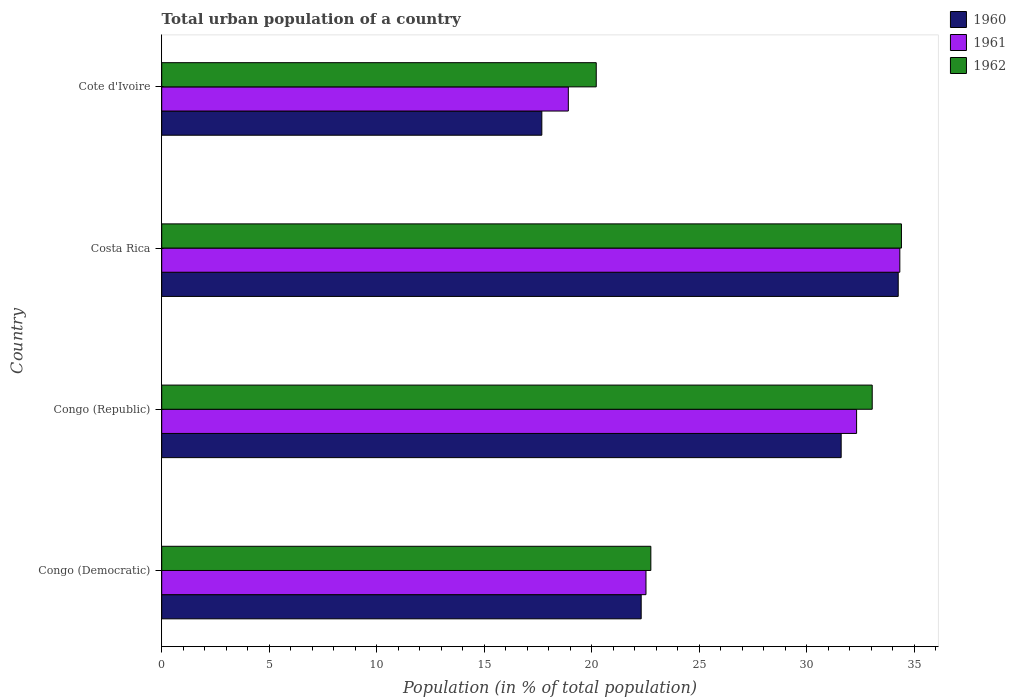How many different coloured bars are there?
Offer a very short reply. 3. How many groups of bars are there?
Offer a very short reply. 4. Are the number of bars per tick equal to the number of legend labels?
Make the answer very short. Yes. Are the number of bars on each tick of the Y-axis equal?
Your response must be concise. Yes. How many bars are there on the 4th tick from the bottom?
Your answer should be compact. 3. What is the label of the 3rd group of bars from the top?
Keep it short and to the point. Congo (Republic). What is the urban population in 1962 in Cote d'Ivoire?
Provide a succinct answer. 20.21. Across all countries, what is the maximum urban population in 1960?
Provide a short and direct response. 34.25. Across all countries, what is the minimum urban population in 1960?
Offer a terse response. 17.68. In which country was the urban population in 1961 minimum?
Provide a short and direct response. Cote d'Ivoire. What is the total urban population in 1962 in the graph?
Give a very brief answer. 110.41. What is the difference between the urban population in 1961 in Congo (Democratic) and that in Cote d'Ivoire?
Provide a short and direct response. 3.61. What is the difference between the urban population in 1962 in Congo (Republic) and the urban population in 1960 in Costa Rica?
Offer a terse response. -1.21. What is the average urban population in 1962 per country?
Keep it short and to the point. 27.6. What is the difference between the urban population in 1962 and urban population in 1960 in Congo (Democratic)?
Your response must be concise. 0.45. In how many countries, is the urban population in 1962 greater than 34 %?
Give a very brief answer. 1. What is the ratio of the urban population in 1962 in Costa Rica to that in Cote d'Ivoire?
Keep it short and to the point. 1.7. Is the urban population in 1960 in Congo (Democratic) less than that in Congo (Republic)?
Your answer should be compact. Yes. Is the difference between the urban population in 1962 in Congo (Republic) and Costa Rica greater than the difference between the urban population in 1960 in Congo (Republic) and Costa Rica?
Keep it short and to the point. Yes. What is the difference between the highest and the second highest urban population in 1962?
Your answer should be very brief. 1.36. What is the difference between the highest and the lowest urban population in 1962?
Your answer should be very brief. 14.19. What does the 3rd bar from the bottom in Congo (Democratic) represents?
Offer a very short reply. 1962. Is it the case that in every country, the sum of the urban population in 1960 and urban population in 1962 is greater than the urban population in 1961?
Give a very brief answer. Yes. How many bars are there?
Make the answer very short. 12. Are all the bars in the graph horizontal?
Offer a very short reply. Yes. Does the graph contain any zero values?
Make the answer very short. No. How many legend labels are there?
Give a very brief answer. 3. How are the legend labels stacked?
Give a very brief answer. Vertical. What is the title of the graph?
Make the answer very short. Total urban population of a country. What is the label or title of the X-axis?
Provide a succinct answer. Population (in % of total population). What is the label or title of the Y-axis?
Offer a terse response. Country. What is the Population (in % of total population) of 1960 in Congo (Democratic)?
Make the answer very short. 22.3. What is the Population (in % of total population) in 1961 in Congo (Democratic)?
Offer a very short reply. 22.52. What is the Population (in % of total population) in 1962 in Congo (Democratic)?
Provide a succinct answer. 22.75. What is the Population (in % of total population) in 1960 in Congo (Republic)?
Your answer should be compact. 31.6. What is the Population (in % of total population) in 1961 in Congo (Republic)?
Your response must be concise. 32.32. What is the Population (in % of total population) in 1962 in Congo (Republic)?
Your answer should be compact. 33.05. What is the Population (in % of total population) of 1960 in Costa Rica?
Your answer should be compact. 34.25. What is the Population (in % of total population) of 1961 in Costa Rica?
Your response must be concise. 34.33. What is the Population (in % of total population) of 1962 in Costa Rica?
Provide a succinct answer. 34.4. What is the Population (in % of total population) of 1960 in Cote d'Ivoire?
Your response must be concise. 17.68. What is the Population (in % of total population) of 1961 in Cote d'Ivoire?
Make the answer very short. 18.91. What is the Population (in % of total population) of 1962 in Cote d'Ivoire?
Your response must be concise. 20.21. Across all countries, what is the maximum Population (in % of total population) of 1960?
Provide a succinct answer. 34.25. Across all countries, what is the maximum Population (in % of total population) in 1961?
Make the answer very short. 34.33. Across all countries, what is the maximum Population (in % of total population) in 1962?
Offer a very short reply. 34.4. Across all countries, what is the minimum Population (in % of total population) in 1960?
Make the answer very short. 17.68. Across all countries, what is the minimum Population (in % of total population) of 1961?
Your response must be concise. 18.91. Across all countries, what is the minimum Population (in % of total population) in 1962?
Provide a succinct answer. 20.21. What is the total Population (in % of total population) of 1960 in the graph?
Your response must be concise. 105.83. What is the total Population (in % of total population) in 1961 in the graph?
Offer a terse response. 108.08. What is the total Population (in % of total population) in 1962 in the graph?
Make the answer very short. 110.41. What is the difference between the Population (in % of total population) in 1960 in Congo (Democratic) and that in Congo (Republic)?
Your answer should be compact. -9.3. What is the difference between the Population (in % of total population) of 1961 in Congo (Democratic) and that in Congo (Republic)?
Your answer should be very brief. -9.79. What is the difference between the Population (in % of total population) of 1962 in Congo (Democratic) and that in Congo (Republic)?
Your answer should be compact. -10.3. What is the difference between the Population (in % of total population) in 1960 in Congo (Democratic) and that in Costa Rica?
Give a very brief answer. -11.95. What is the difference between the Population (in % of total population) of 1961 in Congo (Democratic) and that in Costa Rica?
Give a very brief answer. -11.81. What is the difference between the Population (in % of total population) of 1962 in Congo (Democratic) and that in Costa Rica?
Keep it short and to the point. -11.65. What is the difference between the Population (in % of total population) in 1960 in Congo (Democratic) and that in Cote d'Ivoire?
Offer a very short reply. 4.62. What is the difference between the Population (in % of total population) in 1961 in Congo (Democratic) and that in Cote d'Ivoire?
Ensure brevity in your answer.  3.61. What is the difference between the Population (in % of total population) in 1962 in Congo (Democratic) and that in Cote d'Ivoire?
Provide a succinct answer. 2.54. What is the difference between the Population (in % of total population) of 1960 in Congo (Republic) and that in Costa Rica?
Keep it short and to the point. -2.65. What is the difference between the Population (in % of total population) in 1961 in Congo (Republic) and that in Costa Rica?
Keep it short and to the point. -2.01. What is the difference between the Population (in % of total population) in 1962 in Congo (Republic) and that in Costa Rica?
Provide a succinct answer. -1.36. What is the difference between the Population (in % of total population) in 1960 in Congo (Republic) and that in Cote d'Ivoire?
Make the answer very short. 13.92. What is the difference between the Population (in % of total population) in 1961 in Congo (Republic) and that in Cote d'Ivoire?
Make the answer very short. 13.41. What is the difference between the Population (in % of total population) in 1962 in Congo (Republic) and that in Cote d'Ivoire?
Give a very brief answer. 12.84. What is the difference between the Population (in % of total population) of 1960 in Costa Rica and that in Cote d'Ivoire?
Keep it short and to the point. 16.57. What is the difference between the Population (in % of total population) in 1961 in Costa Rica and that in Cote d'Ivoire?
Keep it short and to the point. 15.42. What is the difference between the Population (in % of total population) in 1962 in Costa Rica and that in Cote d'Ivoire?
Provide a short and direct response. 14.19. What is the difference between the Population (in % of total population) in 1960 in Congo (Democratic) and the Population (in % of total population) in 1961 in Congo (Republic)?
Give a very brief answer. -10.02. What is the difference between the Population (in % of total population) in 1960 in Congo (Democratic) and the Population (in % of total population) in 1962 in Congo (Republic)?
Give a very brief answer. -10.74. What is the difference between the Population (in % of total population) of 1961 in Congo (Democratic) and the Population (in % of total population) of 1962 in Congo (Republic)?
Give a very brief answer. -10.52. What is the difference between the Population (in % of total population) in 1960 in Congo (Democratic) and the Population (in % of total population) in 1961 in Costa Rica?
Offer a very short reply. -12.03. What is the difference between the Population (in % of total population) in 1960 in Congo (Democratic) and the Population (in % of total population) in 1962 in Costa Rica?
Give a very brief answer. -12.1. What is the difference between the Population (in % of total population) in 1961 in Congo (Democratic) and the Population (in % of total population) in 1962 in Costa Rica?
Provide a succinct answer. -11.88. What is the difference between the Population (in % of total population) of 1960 in Congo (Democratic) and the Population (in % of total population) of 1961 in Cote d'Ivoire?
Give a very brief answer. 3.39. What is the difference between the Population (in % of total population) in 1960 in Congo (Democratic) and the Population (in % of total population) in 1962 in Cote d'Ivoire?
Your response must be concise. 2.09. What is the difference between the Population (in % of total population) of 1961 in Congo (Democratic) and the Population (in % of total population) of 1962 in Cote d'Ivoire?
Keep it short and to the point. 2.31. What is the difference between the Population (in % of total population) of 1960 in Congo (Republic) and the Population (in % of total population) of 1961 in Costa Rica?
Keep it short and to the point. -2.73. What is the difference between the Population (in % of total population) in 1960 in Congo (Republic) and the Population (in % of total population) in 1962 in Costa Rica?
Offer a very short reply. -2.8. What is the difference between the Population (in % of total population) of 1961 in Congo (Republic) and the Population (in % of total population) of 1962 in Costa Rica?
Your answer should be very brief. -2.09. What is the difference between the Population (in % of total population) in 1960 in Congo (Republic) and the Population (in % of total population) in 1961 in Cote d'Ivoire?
Your answer should be very brief. 12.69. What is the difference between the Population (in % of total population) of 1960 in Congo (Republic) and the Population (in % of total population) of 1962 in Cote d'Ivoire?
Your response must be concise. 11.39. What is the difference between the Population (in % of total population) of 1961 in Congo (Republic) and the Population (in % of total population) of 1962 in Cote d'Ivoire?
Provide a succinct answer. 12.11. What is the difference between the Population (in % of total population) of 1960 in Costa Rica and the Population (in % of total population) of 1961 in Cote d'Ivoire?
Give a very brief answer. 15.34. What is the difference between the Population (in % of total population) of 1960 in Costa Rica and the Population (in % of total population) of 1962 in Cote d'Ivoire?
Give a very brief answer. 14.04. What is the difference between the Population (in % of total population) of 1961 in Costa Rica and the Population (in % of total population) of 1962 in Cote d'Ivoire?
Offer a very short reply. 14.12. What is the average Population (in % of total population) in 1960 per country?
Provide a succinct answer. 26.46. What is the average Population (in % of total population) in 1961 per country?
Keep it short and to the point. 27.02. What is the average Population (in % of total population) in 1962 per country?
Offer a terse response. 27.6. What is the difference between the Population (in % of total population) in 1960 and Population (in % of total population) in 1961 in Congo (Democratic)?
Give a very brief answer. -0.22. What is the difference between the Population (in % of total population) of 1960 and Population (in % of total population) of 1962 in Congo (Democratic)?
Offer a very short reply. -0.45. What is the difference between the Population (in % of total population) of 1961 and Population (in % of total population) of 1962 in Congo (Democratic)?
Keep it short and to the point. -0.23. What is the difference between the Population (in % of total population) in 1960 and Population (in % of total population) in 1961 in Congo (Republic)?
Offer a terse response. -0.72. What is the difference between the Population (in % of total population) in 1960 and Population (in % of total population) in 1962 in Congo (Republic)?
Your response must be concise. -1.44. What is the difference between the Population (in % of total population) in 1961 and Population (in % of total population) in 1962 in Congo (Republic)?
Make the answer very short. -0.73. What is the difference between the Population (in % of total population) in 1960 and Population (in % of total population) in 1961 in Costa Rica?
Provide a succinct answer. -0.07. What is the difference between the Population (in % of total population) of 1961 and Population (in % of total population) of 1962 in Costa Rica?
Your answer should be very brief. -0.07. What is the difference between the Population (in % of total population) of 1960 and Population (in % of total population) of 1961 in Cote d'Ivoire?
Keep it short and to the point. -1.23. What is the difference between the Population (in % of total population) in 1960 and Population (in % of total population) in 1962 in Cote d'Ivoire?
Provide a short and direct response. -2.53. What is the difference between the Population (in % of total population) of 1961 and Population (in % of total population) of 1962 in Cote d'Ivoire?
Provide a short and direct response. -1.3. What is the ratio of the Population (in % of total population) of 1960 in Congo (Democratic) to that in Congo (Republic)?
Your answer should be very brief. 0.71. What is the ratio of the Population (in % of total population) in 1961 in Congo (Democratic) to that in Congo (Republic)?
Your answer should be compact. 0.7. What is the ratio of the Population (in % of total population) of 1962 in Congo (Democratic) to that in Congo (Republic)?
Ensure brevity in your answer.  0.69. What is the ratio of the Population (in % of total population) of 1960 in Congo (Democratic) to that in Costa Rica?
Make the answer very short. 0.65. What is the ratio of the Population (in % of total population) of 1961 in Congo (Democratic) to that in Costa Rica?
Provide a short and direct response. 0.66. What is the ratio of the Population (in % of total population) in 1962 in Congo (Democratic) to that in Costa Rica?
Give a very brief answer. 0.66. What is the ratio of the Population (in % of total population) in 1960 in Congo (Democratic) to that in Cote d'Ivoire?
Provide a short and direct response. 1.26. What is the ratio of the Population (in % of total population) of 1961 in Congo (Democratic) to that in Cote d'Ivoire?
Your answer should be compact. 1.19. What is the ratio of the Population (in % of total population) in 1962 in Congo (Democratic) to that in Cote d'Ivoire?
Ensure brevity in your answer.  1.13. What is the ratio of the Population (in % of total population) of 1960 in Congo (Republic) to that in Costa Rica?
Offer a terse response. 0.92. What is the ratio of the Population (in % of total population) of 1961 in Congo (Republic) to that in Costa Rica?
Provide a succinct answer. 0.94. What is the ratio of the Population (in % of total population) of 1962 in Congo (Republic) to that in Costa Rica?
Keep it short and to the point. 0.96. What is the ratio of the Population (in % of total population) in 1960 in Congo (Republic) to that in Cote d'Ivoire?
Ensure brevity in your answer.  1.79. What is the ratio of the Population (in % of total population) in 1961 in Congo (Republic) to that in Cote d'Ivoire?
Keep it short and to the point. 1.71. What is the ratio of the Population (in % of total population) of 1962 in Congo (Republic) to that in Cote d'Ivoire?
Offer a very short reply. 1.64. What is the ratio of the Population (in % of total population) in 1960 in Costa Rica to that in Cote d'Ivoire?
Provide a short and direct response. 1.94. What is the ratio of the Population (in % of total population) in 1961 in Costa Rica to that in Cote d'Ivoire?
Keep it short and to the point. 1.82. What is the ratio of the Population (in % of total population) of 1962 in Costa Rica to that in Cote d'Ivoire?
Provide a short and direct response. 1.7. What is the difference between the highest and the second highest Population (in % of total population) of 1960?
Keep it short and to the point. 2.65. What is the difference between the highest and the second highest Population (in % of total population) in 1961?
Offer a terse response. 2.01. What is the difference between the highest and the second highest Population (in % of total population) of 1962?
Your answer should be compact. 1.36. What is the difference between the highest and the lowest Population (in % of total population) of 1960?
Provide a succinct answer. 16.57. What is the difference between the highest and the lowest Population (in % of total population) of 1961?
Your answer should be very brief. 15.42. What is the difference between the highest and the lowest Population (in % of total population) in 1962?
Keep it short and to the point. 14.19. 